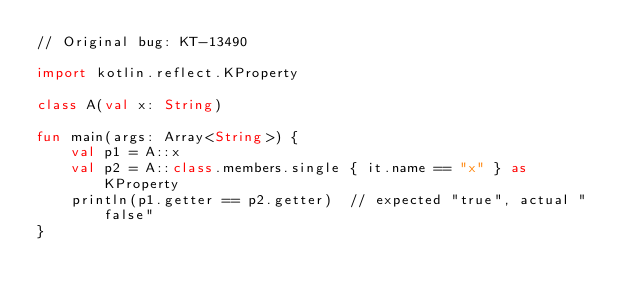<code> <loc_0><loc_0><loc_500><loc_500><_Kotlin_>// Original bug: KT-13490

import kotlin.reflect.KProperty

class A(val x: String)

fun main(args: Array<String>) {
    val p1 = A::x
    val p2 = A::class.members.single { it.name == "x" } as KProperty
    println(p1.getter == p2.getter)  // expected "true", actual "false"
}
</code> 